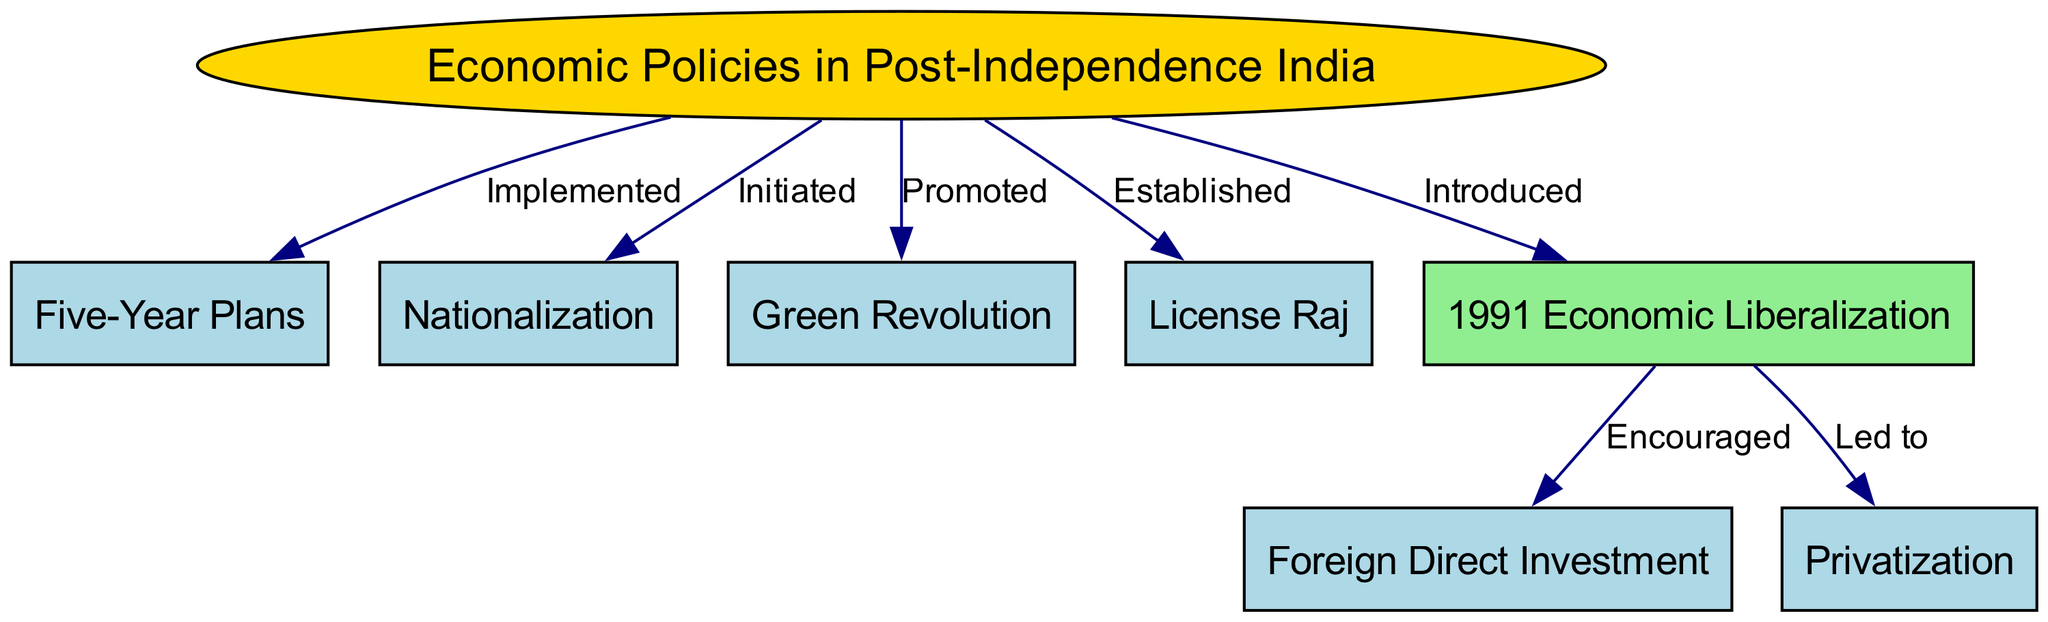What is the central theme of the diagram? The central theme, located at the top node, is "Economic Policies in Post-Independence India." This is indicated as the starting point from which various policies branch out.
Answer: Economic Policies in Post-Independence India How many nodes are present in the diagram? The number of nodes can be counted directly in the diagram, leading to a total of 8 distinct nodes that represent various economic policies and reforms.
Answer: 8 Which policy is connected to "Nationalization"? Tracing the edge from the central theme node to "Nationalization," the relationship indicates that it is an economic policy that was initiated in post-independence India.
Answer: Initiated What relationship exists between "1991 Economic Liberalization" and "Foreign Direct Investment"? The edge drawn from "1991 Economic Liberalization" to "Foreign Direct Investment" indicates that liberalization encouraged foreign direct investment as part of economic reforms.
Answer: Encouraged What color represents the "1991 Economic Liberalization" node? Upon reviewing the diagram, the node representing "1991 Economic Liberalization" is filled in light green, signifying its uniqueness among the policies displayed.
Answer: Light green Which reform led to "Privatization"? The flow from "1991 Economic Liberalization" to "Privatization" suggests that the economic liberalization reforms led to further steps toward privatization in India.
Answer: Led to How many edges are connecting from the central node? By examining the edges stemming from the central node "Economic Policies in Post-Independence India," we find that there are 4 distinct edges connecting to other policies.
Answer: 4 What is the label for the edge between "Five-Year Plans" and the central theme? The edge connecting "Five-Year Plans" back to the central theme is labeled as "Implemented," indicating that it is a key economic policy that was actively put into place.
Answer: Implemented Which node is considered the starting point for many reforms shown in the diagram? The node "1991 Economic Liberalization," marked as an important reform, serves as the starting point for further reforms like foreign direct investment and privatization.
Answer: 1991 Economic Liberalization 